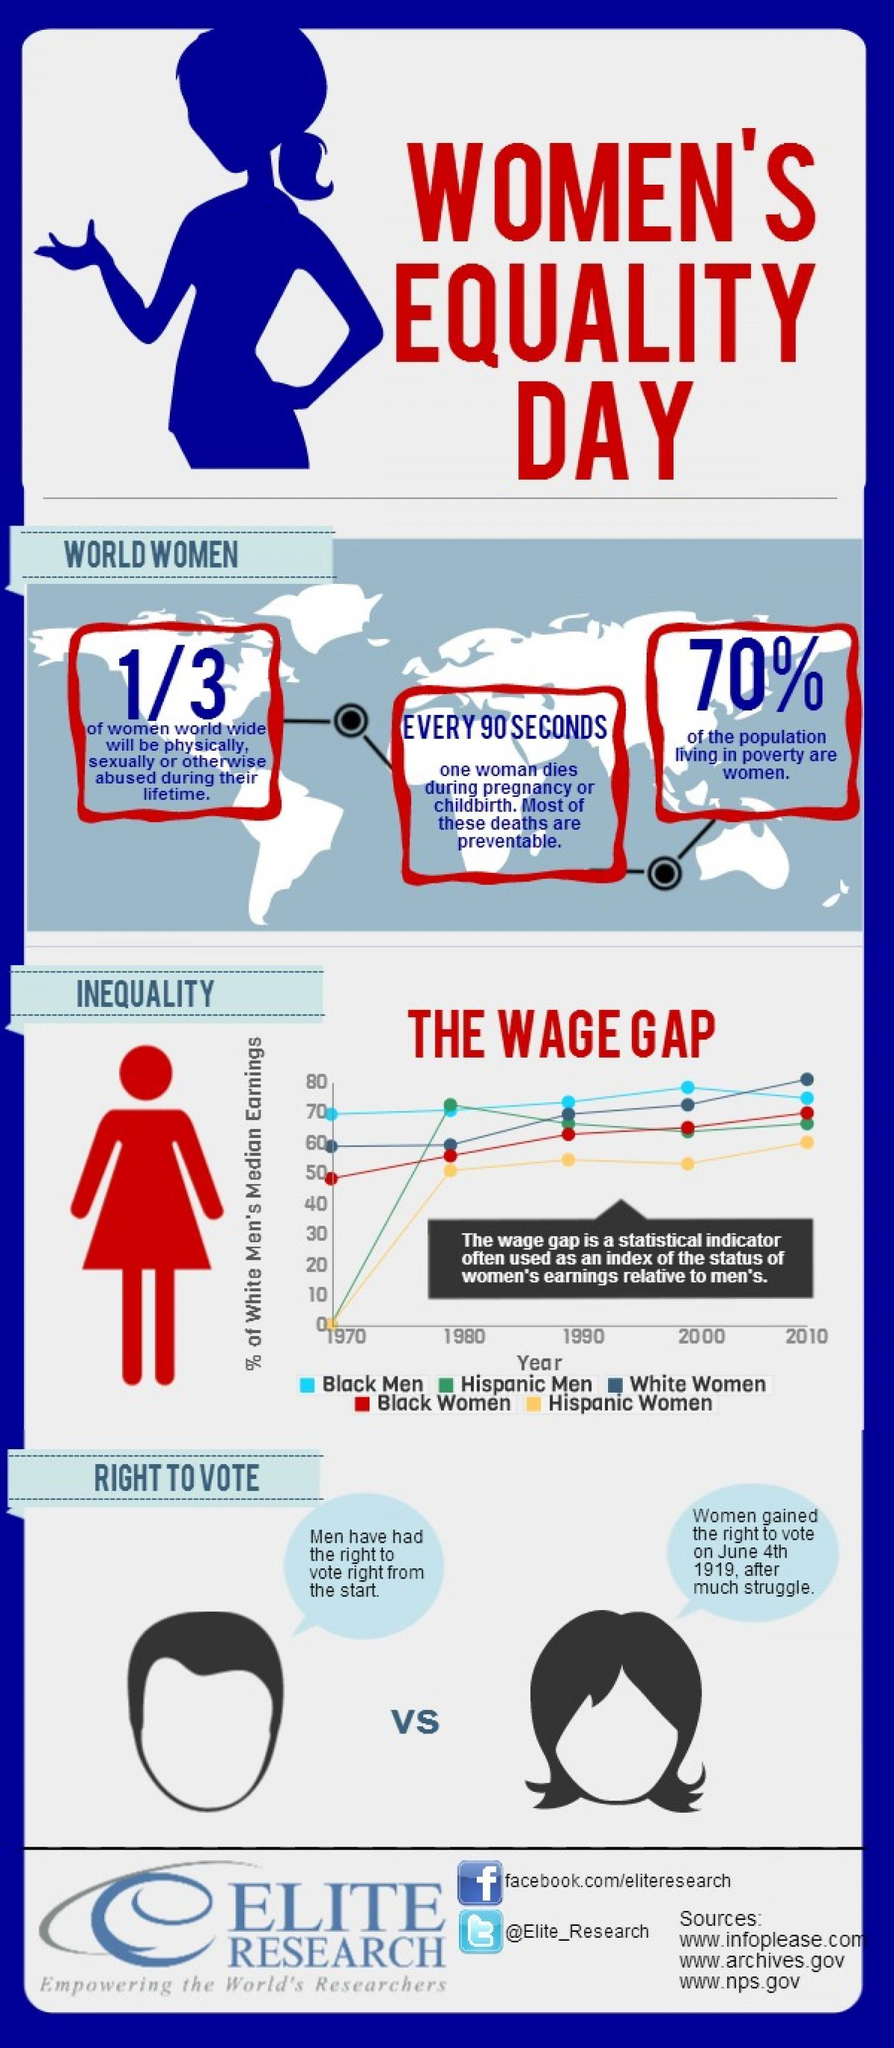In the wage gap graph, who is represented using green line?
Answer the question with a short phrase. Hispanic Men By which colour is Black women represented in the wage gap graph- red, yellow or blue? red How many sources are listed at the bottom? 3 What is the Twitter handle given? @Elite_Research Which groups of people had their wages start from 0 % in 1970s? Hispanic Men, Hispanic Women 